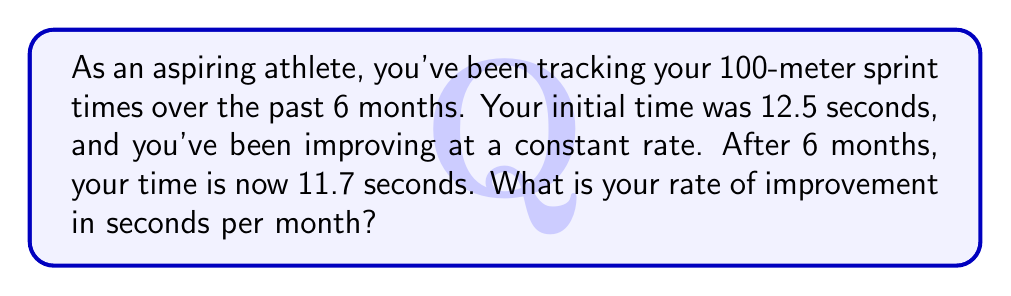Solve this math problem. Let's approach this step-by-step:

1) First, let's identify the important information:
   - Initial time: 12.5 seconds
   - Final time: 11.7 seconds
   - Time period: 6 months

2) To find the rate of improvement, we need to:
   a) Calculate the total improvement
   b) Divide the total improvement by the number of months

3) Calculate the total improvement:
   $\text{Total improvement} = \text{Initial time} - \text{Final time}$
   $\text{Total improvement} = 12.5 - 11.7 = 0.8$ seconds

4) Now, let's calculate the rate of improvement per month:
   $\text{Rate of improvement} = \frac{\text{Total improvement}}{\text{Number of months}}$
   
   $\text{Rate of improvement} = \frac{0.8 \text{ seconds}}{6 \text{ months}}$

5) Simplify the fraction:
   $\text{Rate of improvement} = \frac{0.8}{6} = \frac{4}{30} = \frac{2}{15} = 0.1333...$

6) Round to 3 decimal places:
   $\text{Rate of improvement} \approx 0.133$ seconds per month

Therefore, your rate of improvement is approximately 0.133 seconds per month.
Answer: 0.133 seconds/month 